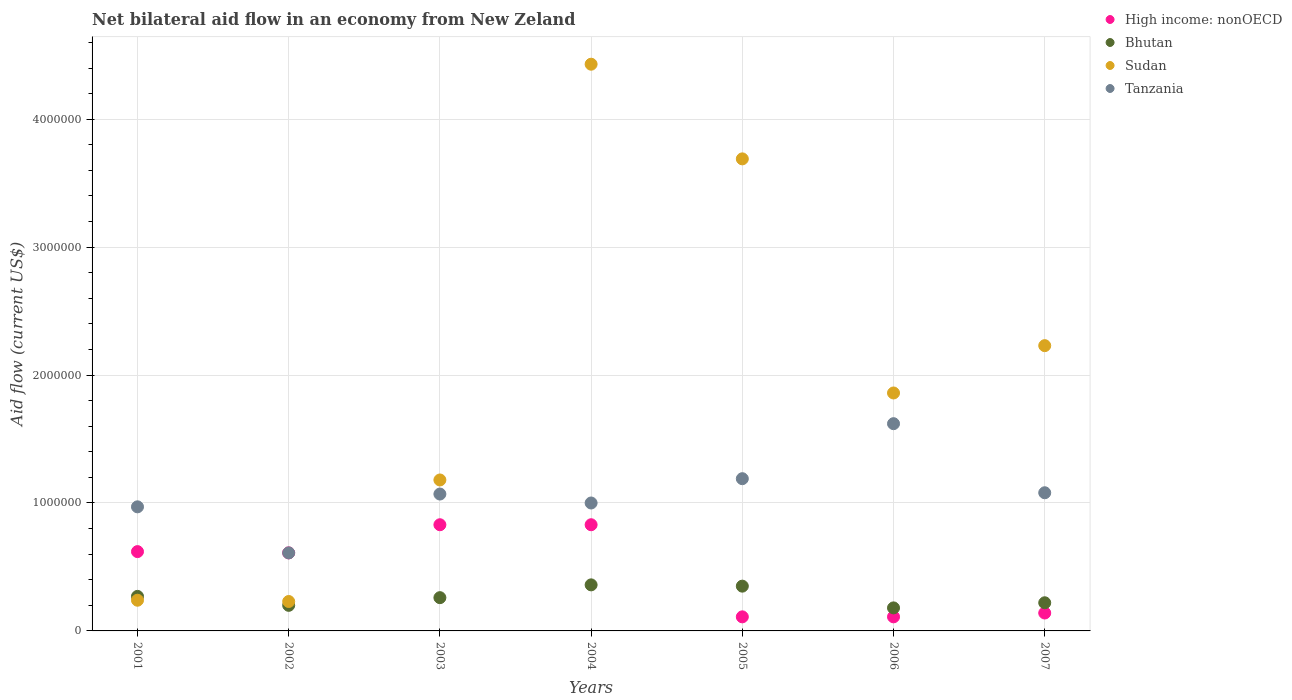Is the number of dotlines equal to the number of legend labels?
Your answer should be very brief. Yes. What is the net bilateral aid flow in Sudan in 2003?
Offer a terse response. 1.18e+06. Across all years, what is the maximum net bilateral aid flow in High income: nonOECD?
Make the answer very short. 8.30e+05. In which year was the net bilateral aid flow in Sudan maximum?
Provide a succinct answer. 2004. What is the total net bilateral aid flow in Tanzania in the graph?
Offer a very short reply. 7.54e+06. What is the difference between the net bilateral aid flow in High income: nonOECD in 2006 and that in 2007?
Offer a terse response. -3.00e+04. What is the difference between the net bilateral aid flow in High income: nonOECD in 2004 and the net bilateral aid flow in Sudan in 2003?
Your answer should be compact. -3.50e+05. What is the average net bilateral aid flow in Sudan per year?
Your answer should be compact. 1.98e+06. In the year 2005, what is the difference between the net bilateral aid flow in Bhutan and net bilateral aid flow in Sudan?
Offer a terse response. -3.34e+06. What is the ratio of the net bilateral aid flow in Bhutan in 2002 to that in 2004?
Offer a terse response. 0.56. Is the net bilateral aid flow in Sudan in 2005 less than that in 2006?
Keep it short and to the point. No. Is the difference between the net bilateral aid flow in Bhutan in 2003 and 2005 greater than the difference between the net bilateral aid flow in Sudan in 2003 and 2005?
Provide a succinct answer. Yes. What is the difference between the highest and the lowest net bilateral aid flow in Bhutan?
Make the answer very short. 1.80e+05. In how many years, is the net bilateral aid flow in Tanzania greater than the average net bilateral aid flow in Tanzania taken over all years?
Make the answer very short. 3. Is the sum of the net bilateral aid flow in Sudan in 2003 and 2007 greater than the maximum net bilateral aid flow in Bhutan across all years?
Ensure brevity in your answer.  Yes. Is it the case that in every year, the sum of the net bilateral aid flow in Tanzania and net bilateral aid flow in Sudan  is greater than the net bilateral aid flow in Bhutan?
Offer a terse response. Yes. Is the net bilateral aid flow in Tanzania strictly less than the net bilateral aid flow in High income: nonOECD over the years?
Give a very brief answer. No. How many dotlines are there?
Ensure brevity in your answer.  4. How many years are there in the graph?
Provide a succinct answer. 7. Are the values on the major ticks of Y-axis written in scientific E-notation?
Provide a short and direct response. No. Does the graph contain any zero values?
Ensure brevity in your answer.  No. Does the graph contain grids?
Offer a very short reply. Yes. How many legend labels are there?
Ensure brevity in your answer.  4. How are the legend labels stacked?
Give a very brief answer. Vertical. What is the title of the graph?
Provide a short and direct response. Net bilateral aid flow in an economy from New Zeland. What is the Aid flow (current US$) in High income: nonOECD in 2001?
Your answer should be compact. 6.20e+05. What is the Aid flow (current US$) of Bhutan in 2001?
Make the answer very short. 2.70e+05. What is the Aid flow (current US$) in Tanzania in 2001?
Offer a very short reply. 9.70e+05. What is the Aid flow (current US$) of High income: nonOECD in 2002?
Provide a succinct answer. 6.10e+05. What is the Aid flow (current US$) in Sudan in 2002?
Ensure brevity in your answer.  2.30e+05. What is the Aid flow (current US$) of High income: nonOECD in 2003?
Give a very brief answer. 8.30e+05. What is the Aid flow (current US$) in Bhutan in 2003?
Ensure brevity in your answer.  2.60e+05. What is the Aid flow (current US$) in Sudan in 2003?
Provide a succinct answer. 1.18e+06. What is the Aid flow (current US$) of Tanzania in 2003?
Your answer should be very brief. 1.07e+06. What is the Aid flow (current US$) of High income: nonOECD in 2004?
Offer a very short reply. 8.30e+05. What is the Aid flow (current US$) in Bhutan in 2004?
Provide a short and direct response. 3.60e+05. What is the Aid flow (current US$) in Sudan in 2004?
Offer a terse response. 4.43e+06. What is the Aid flow (current US$) in High income: nonOECD in 2005?
Offer a very short reply. 1.10e+05. What is the Aid flow (current US$) of Bhutan in 2005?
Ensure brevity in your answer.  3.50e+05. What is the Aid flow (current US$) in Sudan in 2005?
Your answer should be very brief. 3.69e+06. What is the Aid flow (current US$) of Tanzania in 2005?
Your answer should be compact. 1.19e+06. What is the Aid flow (current US$) of High income: nonOECD in 2006?
Offer a very short reply. 1.10e+05. What is the Aid flow (current US$) of Sudan in 2006?
Give a very brief answer. 1.86e+06. What is the Aid flow (current US$) of Tanzania in 2006?
Give a very brief answer. 1.62e+06. What is the Aid flow (current US$) in High income: nonOECD in 2007?
Your response must be concise. 1.40e+05. What is the Aid flow (current US$) of Sudan in 2007?
Offer a terse response. 2.23e+06. What is the Aid flow (current US$) of Tanzania in 2007?
Your answer should be very brief. 1.08e+06. Across all years, what is the maximum Aid flow (current US$) of High income: nonOECD?
Your answer should be very brief. 8.30e+05. Across all years, what is the maximum Aid flow (current US$) of Bhutan?
Provide a succinct answer. 3.60e+05. Across all years, what is the maximum Aid flow (current US$) in Sudan?
Give a very brief answer. 4.43e+06. Across all years, what is the maximum Aid flow (current US$) of Tanzania?
Offer a terse response. 1.62e+06. Across all years, what is the minimum Aid flow (current US$) in Bhutan?
Keep it short and to the point. 1.80e+05. Across all years, what is the minimum Aid flow (current US$) in Tanzania?
Give a very brief answer. 6.10e+05. What is the total Aid flow (current US$) of High income: nonOECD in the graph?
Provide a succinct answer. 3.25e+06. What is the total Aid flow (current US$) of Bhutan in the graph?
Your answer should be very brief. 1.84e+06. What is the total Aid flow (current US$) of Sudan in the graph?
Make the answer very short. 1.39e+07. What is the total Aid flow (current US$) in Tanzania in the graph?
Make the answer very short. 7.54e+06. What is the difference between the Aid flow (current US$) of High income: nonOECD in 2001 and that in 2002?
Your response must be concise. 10000. What is the difference between the Aid flow (current US$) of Sudan in 2001 and that in 2002?
Keep it short and to the point. 10000. What is the difference between the Aid flow (current US$) in Tanzania in 2001 and that in 2002?
Make the answer very short. 3.60e+05. What is the difference between the Aid flow (current US$) in High income: nonOECD in 2001 and that in 2003?
Your answer should be very brief. -2.10e+05. What is the difference between the Aid flow (current US$) of Sudan in 2001 and that in 2003?
Your response must be concise. -9.40e+05. What is the difference between the Aid flow (current US$) in Tanzania in 2001 and that in 2003?
Make the answer very short. -1.00e+05. What is the difference between the Aid flow (current US$) of Sudan in 2001 and that in 2004?
Make the answer very short. -4.19e+06. What is the difference between the Aid flow (current US$) of High income: nonOECD in 2001 and that in 2005?
Provide a succinct answer. 5.10e+05. What is the difference between the Aid flow (current US$) in Bhutan in 2001 and that in 2005?
Your response must be concise. -8.00e+04. What is the difference between the Aid flow (current US$) in Sudan in 2001 and that in 2005?
Offer a terse response. -3.45e+06. What is the difference between the Aid flow (current US$) of High income: nonOECD in 2001 and that in 2006?
Your answer should be very brief. 5.10e+05. What is the difference between the Aid flow (current US$) of Sudan in 2001 and that in 2006?
Make the answer very short. -1.62e+06. What is the difference between the Aid flow (current US$) in Tanzania in 2001 and that in 2006?
Give a very brief answer. -6.50e+05. What is the difference between the Aid flow (current US$) of High income: nonOECD in 2001 and that in 2007?
Provide a succinct answer. 4.80e+05. What is the difference between the Aid flow (current US$) of Sudan in 2001 and that in 2007?
Your answer should be compact. -1.99e+06. What is the difference between the Aid flow (current US$) of Tanzania in 2001 and that in 2007?
Your answer should be compact. -1.10e+05. What is the difference between the Aid flow (current US$) in Sudan in 2002 and that in 2003?
Make the answer very short. -9.50e+05. What is the difference between the Aid flow (current US$) in Tanzania in 2002 and that in 2003?
Give a very brief answer. -4.60e+05. What is the difference between the Aid flow (current US$) in Bhutan in 2002 and that in 2004?
Offer a terse response. -1.60e+05. What is the difference between the Aid flow (current US$) of Sudan in 2002 and that in 2004?
Your answer should be very brief. -4.20e+06. What is the difference between the Aid flow (current US$) in Tanzania in 2002 and that in 2004?
Provide a short and direct response. -3.90e+05. What is the difference between the Aid flow (current US$) of High income: nonOECD in 2002 and that in 2005?
Your response must be concise. 5.00e+05. What is the difference between the Aid flow (current US$) in Sudan in 2002 and that in 2005?
Make the answer very short. -3.46e+06. What is the difference between the Aid flow (current US$) of Tanzania in 2002 and that in 2005?
Give a very brief answer. -5.80e+05. What is the difference between the Aid flow (current US$) of High income: nonOECD in 2002 and that in 2006?
Offer a very short reply. 5.00e+05. What is the difference between the Aid flow (current US$) in Bhutan in 2002 and that in 2006?
Offer a very short reply. 2.00e+04. What is the difference between the Aid flow (current US$) in Sudan in 2002 and that in 2006?
Your answer should be compact. -1.63e+06. What is the difference between the Aid flow (current US$) in Tanzania in 2002 and that in 2006?
Keep it short and to the point. -1.01e+06. What is the difference between the Aid flow (current US$) of Sudan in 2002 and that in 2007?
Keep it short and to the point. -2.00e+06. What is the difference between the Aid flow (current US$) in Tanzania in 2002 and that in 2007?
Give a very brief answer. -4.70e+05. What is the difference between the Aid flow (current US$) in Sudan in 2003 and that in 2004?
Provide a succinct answer. -3.25e+06. What is the difference between the Aid flow (current US$) in Tanzania in 2003 and that in 2004?
Provide a succinct answer. 7.00e+04. What is the difference between the Aid flow (current US$) of High income: nonOECD in 2003 and that in 2005?
Your answer should be compact. 7.20e+05. What is the difference between the Aid flow (current US$) of Bhutan in 2003 and that in 2005?
Provide a succinct answer. -9.00e+04. What is the difference between the Aid flow (current US$) of Sudan in 2003 and that in 2005?
Your answer should be compact. -2.51e+06. What is the difference between the Aid flow (current US$) of Tanzania in 2003 and that in 2005?
Provide a short and direct response. -1.20e+05. What is the difference between the Aid flow (current US$) of High income: nonOECD in 2003 and that in 2006?
Your answer should be compact. 7.20e+05. What is the difference between the Aid flow (current US$) in Bhutan in 2003 and that in 2006?
Offer a terse response. 8.00e+04. What is the difference between the Aid flow (current US$) of Sudan in 2003 and that in 2006?
Your answer should be compact. -6.80e+05. What is the difference between the Aid flow (current US$) of Tanzania in 2003 and that in 2006?
Offer a very short reply. -5.50e+05. What is the difference between the Aid flow (current US$) of High income: nonOECD in 2003 and that in 2007?
Keep it short and to the point. 6.90e+05. What is the difference between the Aid flow (current US$) of Sudan in 2003 and that in 2007?
Provide a succinct answer. -1.05e+06. What is the difference between the Aid flow (current US$) in Tanzania in 2003 and that in 2007?
Provide a succinct answer. -10000. What is the difference between the Aid flow (current US$) of High income: nonOECD in 2004 and that in 2005?
Your answer should be very brief. 7.20e+05. What is the difference between the Aid flow (current US$) in Bhutan in 2004 and that in 2005?
Your answer should be very brief. 10000. What is the difference between the Aid flow (current US$) of Sudan in 2004 and that in 2005?
Offer a terse response. 7.40e+05. What is the difference between the Aid flow (current US$) of High income: nonOECD in 2004 and that in 2006?
Offer a terse response. 7.20e+05. What is the difference between the Aid flow (current US$) in Sudan in 2004 and that in 2006?
Provide a short and direct response. 2.57e+06. What is the difference between the Aid flow (current US$) in Tanzania in 2004 and that in 2006?
Your answer should be compact. -6.20e+05. What is the difference between the Aid flow (current US$) of High income: nonOECD in 2004 and that in 2007?
Your answer should be compact. 6.90e+05. What is the difference between the Aid flow (current US$) in Bhutan in 2004 and that in 2007?
Keep it short and to the point. 1.40e+05. What is the difference between the Aid flow (current US$) in Sudan in 2004 and that in 2007?
Ensure brevity in your answer.  2.20e+06. What is the difference between the Aid flow (current US$) in Tanzania in 2004 and that in 2007?
Ensure brevity in your answer.  -8.00e+04. What is the difference between the Aid flow (current US$) of High income: nonOECD in 2005 and that in 2006?
Offer a terse response. 0. What is the difference between the Aid flow (current US$) in Sudan in 2005 and that in 2006?
Ensure brevity in your answer.  1.83e+06. What is the difference between the Aid flow (current US$) in Tanzania in 2005 and that in 2006?
Give a very brief answer. -4.30e+05. What is the difference between the Aid flow (current US$) of Sudan in 2005 and that in 2007?
Your answer should be compact. 1.46e+06. What is the difference between the Aid flow (current US$) in Tanzania in 2005 and that in 2007?
Give a very brief answer. 1.10e+05. What is the difference between the Aid flow (current US$) of Bhutan in 2006 and that in 2007?
Make the answer very short. -4.00e+04. What is the difference between the Aid flow (current US$) of Sudan in 2006 and that in 2007?
Make the answer very short. -3.70e+05. What is the difference between the Aid flow (current US$) of Tanzania in 2006 and that in 2007?
Your response must be concise. 5.40e+05. What is the difference between the Aid flow (current US$) of High income: nonOECD in 2001 and the Aid flow (current US$) of Bhutan in 2002?
Your response must be concise. 4.20e+05. What is the difference between the Aid flow (current US$) in High income: nonOECD in 2001 and the Aid flow (current US$) in Sudan in 2002?
Keep it short and to the point. 3.90e+05. What is the difference between the Aid flow (current US$) of High income: nonOECD in 2001 and the Aid flow (current US$) of Tanzania in 2002?
Provide a succinct answer. 10000. What is the difference between the Aid flow (current US$) in Bhutan in 2001 and the Aid flow (current US$) in Sudan in 2002?
Your answer should be very brief. 4.00e+04. What is the difference between the Aid flow (current US$) in Bhutan in 2001 and the Aid flow (current US$) in Tanzania in 2002?
Give a very brief answer. -3.40e+05. What is the difference between the Aid flow (current US$) in Sudan in 2001 and the Aid flow (current US$) in Tanzania in 2002?
Ensure brevity in your answer.  -3.70e+05. What is the difference between the Aid flow (current US$) in High income: nonOECD in 2001 and the Aid flow (current US$) in Sudan in 2003?
Ensure brevity in your answer.  -5.60e+05. What is the difference between the Aid flow (current US$) in High income: nonOECD in 2001 and the Aid flow (current US$) in Tanzania in 2003?
Ensure brevity in your answer.  -4.50e+05. What is the difference between the Aid flow (current US$) in Bhutan in 2001 and the Aid flow (current US$) in Sudan in 2003?
Offer a very short reply. -9.10e+05. What is the difference between the Aid flow (current US$) in Bhutan in 2001 and the Aid flow (current US$) in Tanzania in 2003?
Ensure brevity in your answer.  -8.00e+05. What is the difference between the Aid flow (current US$) of Sudan in 2001 and the Aid flow (current US$) of Tanzania in 2003?
Your answer should be compact. -8.30e+05. What is the difference between the Aid flow (current US$) of High income: nonOECD in 2001 and the Aid flow (current US$) of Sudan in 2004?
Your response must be concise. -3.81e+06. What is the difference between the Aid flow (current US$) in High income: nonOECD in 2001 and the Aid flow (current US$) in Tanzania in 2004?
Ensure brevity in your answer.  -3.80e+05. What is the difference between the Aid flow (current US$) in Bhutan in 2001 and the Aid flow (current US$) in Sudan in 2004?
Your answer should be very brief. -4.16e+06. What is the difference between the Aid flow (current US$) of Bhutan in 2001 and the Aid flow (current US$) of Tanzania in 2004?
Ensure brevity in your answer.  -7.30e+05. What is the difference between the Aid flow (current US$) in Sudan in 2001 and the Aid flow (current US$) in Tanzania in 2004?
Keep it short and to the point. -7.60e+05. What is the difference between the Aid flow (current US$) in High income: nonOECD in 2001 and the Aid flow (current US$) in Sudan in 2005?
Offer a very short reply. -3.07e+06. What is the difference between the Aid flow (current US$) of High income: nonOECD in 2001 and the Aid flow (current US$) of Tanzania in 2005?
Your answer should be very brief. -5.70e+05. What is the difference between the Aid flow (current US$) of Bhutan in 2001 and the Aid flow (current US$) of Sudan in 2005?
Your answer should be compact. -3.42e+06. What is the difference between the Aid flow (current US$) of Bhutan in 2001 and the Aid flow (current US$) of Tanzania in 2005?
Give a very brief answer. -9.20e+05. What is the difference between the Aid flow (current US$) of Sudan in 2001 and the Aid flow (current US$) of Tanzania in 2005?
Offer a terse response. -9.50e+05. What is the difference between the Aid flow (current US$) of High income: nonOECD in 2001 and the Aid flow (current US$) of Bhutan in 2006?
Keep it short and to the point. 4.40e+05. What is the difference between the Aid flow (current US$) in High income: nonOECD in 2001 and the Aid flow (current US$) in Sudan in 2006?
Give a very brief answer. -1.24e+06. What is the difference between the Aid flow (current US$) of Bhutan in 2001 and the Aid flow (current US$) of Sudan in 2006?
Ensure brevity in your answer.  -1.59e+06. What is the difference between the Aid flow (current US$) of Bhutan in 2001 and the Aid flow (current US$) of Tanzania in 2006?
Your answer should be compact. -1.35e+06. What is the difference between the Aid flow (current US$) in Sudan in 2001 and the Aid flow (current US$) in Tanzania in 2006?
Provide a short and direct response. -1.38e+06. What is the difference between the Aid flow (current US$) of High income: nonOECD in 2001 and the Aid flow (current US$) of Bhutan in 2007?
Offer a very short reply. 4.00e+05. What is the difference between the Aid flow (current US$) in High income: nonOECD in 2001 and the Aid flow (current US$) in Sudan in 2007?
Make the answer very short. -1.61e+06. What is the difference between the Aid flow (current US$) of High income: nonOECD in 2001 and the Aid flow (current US$) of Tanzania in 2007?
Offer a terse response. -4.60e+05. What is the difference between the Aid flow (current US$) of Bhutan in 2001 and the Aid flow (current US$) of Sudan in 2007?
Give a very brief answer. -1.96e+06. What is the difference between the Aid flow (current US$) of Bhutan in 2001 and the Aid flow (current US$) of Tanzania in 2007?
Provide a short and direct response. -8.10e+05. What is the difference between the Aid flow (current US$) of Sudan in 2001 and the Aid flow (current US$) of Tanzania in 2007?
Give a very brief answer. -8.40e+05. What is the difference between the Aid flow (current US$) of High income: nonOECD in 2002 and the Aid flow (current US$) of Sudan in 2003?
Provide a short and direct response. -5.70e+05. What is the difference between the Aid flow (current US$) in High income: nonOECD in 2002 and the Aid flow (current US$) in Tanzania in 2003?
Make the answer very short. -4.60e+05. What is the difference between the Aid flow (current US$) in Bhutan in 2002 and the Aid flow (current US$) in Sudan in 2003?
Your answer should be very brief. -9.80e+05. What is the difference between the Aid flow (current US$) of Bhutan in 2002 and the Aid flow (current US$) of Tanzania in 2003?
Give a very brief answer. -8.70e+05. What is the difference between the Aid flow (current US$) of Sudan in 2002 and the Aid flow (current US$) of Tanzania in 2003?
Your response must be concise. -8.40e+05. What is the difference between the Aid flow (current US$) in High income: nonOECD in 2002 and the Aid flow (current US$) in Sudan in 2004?
Ensure brevity in your answer.  -3.82e+06. What is the difference between the Aid flow (current US$) of High income: nonOECD in 2002 and the Aid flow (current US$) of Tanzania in 2004?
Offer a terse response. -3.90e+05. What is the difference between the Aid flow (current US$) of Bhutan in 2002 and the Aid flow (current US$) of Sudan in 2004?
Give a very brief answer. -4.23e+06. What is the difference between the Aid flow (current US$) in Bhutan in 2002 and the Aid flow (current US$) in Tanzania in 2004?
Your answer should be compact. -8.00e+05. What is the difference between the Aid flow (current US$) in Sudan in 2002 and the Aid flow (current US$) in Tanzania in 2004?
Make the answer very short. -7.70e+05. What is the difference between the Aid flow (current US$) in High income: nonOECD in 2002 and the Aid flow (current US$) in Sudan in 2005?
Your answer should be compact. -3.08e+06. What is the difference between the Aid flow (current US$) in High income: nonOECD in 2002 and the Aid flow (current US$) in Tanzania in 2005?
Offer a very short reply. -5.80e+05. What is the difference between the Aid flow (current US$) of Bhutan in 2002 and the Aid flow (current US$) of Sudan in 2005?
Offer a very short reply. -3.49e+06. What is the difference between the Aid flow (current US$) of Bhutan in 2002 and the Aid flow (current US$) of Tanzania in 2005?
Give a very brief answer. -9.90e+05. What is the difference between the Aid flow (current US$) of Sudan in 2002 and the Aid flow (current US$) of Tanzania in 2005?
Your answer should be compact. -9.60e+05. What is the difference between the Aid flow (current US$) of High income: nonOECD in 2002 and the Aid flow (current US$) of Bhutan in 2006?
Ensure brevity in your answer.  4.30e+05. What is the difference between the Aid flow (current US$) of High income: nonOECD in 2002 and the Aid flow (current US$) of Sudan in 2006?
Give a very brief answer. -1.25e+06. What is the difference between the Aid flow (current US$) of High income: nonOECD in 2002 and the Aid flow (current US$) of Tanzania in 2006?
Offer a terse response. -1.01e+06. What is the difference between the Aid flow (current US$) of Bhutan in 2002 and the Aid flow (current US$) of Sudan in 2006?
Make the answer very short. -1.66e+06. What is the difference between the Aid flow (current US$) in Bhutan in 2002 and the Aid flow (current US$) in Tanzania in 2006?
Give a very brief answer. -1.42e+06. What is the difference between the Aid flow (current US$) of Sudan in 2002 and the Aid flow (current US$) of Tanzania in 2006?
Provide a short and direct response. -1.39e+06. What is the difference between the Aid flow (current US$) of High income: nonOECD in 2002 and the Aid flow (current US$) of Bhutan in 2007?
Give a very brief answer. 3.90e+05. What is the difference between the Aid flow (current US$) of High income: nonOECD in 2002 and the Aid flow (current US$) of Sudan in 2007?
Ensure brevity in your answer.  -1.62e+06. What is the difference between the Aid flow (current US$) in High income: nonOECD in 2002 and the Aid flow (current US$) in Tanzania in 2007?
Give a very brief answer. -4.70e+05. What is the difference between the Aid flow (current US$) in Bhutan in 2002 and the Aid flow (current US$) in Sudan in 2007?
Give a very brief answer. -2.03e+06. What is the difference between the Aid flow (current US$) of Bhutan in 2002 and the Aid flow (current US$) of Tanzania in 2007?
Your response must be concise. -8.80e+05. What is the difference between the Aid flow (current US$) in Sudan in 2002 and the Aid flow (current US$) in Tanzania in 2007?
Keep it short and to the point. -8.50e+05. What is the difference between the Aid flow (current US$) of High income: nonOECD in 2003 and the Aid flow (current US$) of Sudan in 2004?
Provide a succinct answer. -3.60e+06. What is the difference between the Aid flow (current US$) in High income: nonOECD in 2003 and the Aid flow (current US$) in Tanzania in 2004?
Offer a terse response. -1.70e+05. What is the difference between the Aid flow (current US$) of Bhutan in 2003 and the Aid flow (current US$) of Sudan in 2004?
Provide a short and direct response. -4.17e+06. What is the difference between the Aid flow (current US$) of Bhutan in 2003 and the Aid flow (current US$) of Tanzania in 2004?
Offer a very short reply. -7.40e+05. What is the difference between the Aid flow (current US$) of High income: nonOECD in 2003 and the Aid flow (current US$) of Bhutan in 2005?
Your answer should be compact. 4.80e+05. What is the difference between the Aid flow (current US$) in High income: nonOECD in 2003 and the Aid flow (current US$) in Sudan in 2005?
Give a very brief answer. -2.86e+06. What is the difference between the Aid flow (current US$) of High income: nonOECD in 2003 and the Aid flow (current US$) of Tanzania in 2005?
Your response must be concise. -3.60e+05. What is the difference between the Aid flow (current US$) in Bhutan in 2003 and the Aid flow (current US$) in Sudan in 2005?
Your answer should be compact. -3.43e+06. What is the difference between the Aid flow (current US$) of Bhutan in 2003 and the Aid flow (current US$) of Tanzania in 2005?
Offer a terse response. -9.30e+05. What is the difference between the Aid flow (current US$) in High income: nonOECD in 2003 and the Aid flow (current US$) in Bhutan in 2006?
Provide a short and direct response. 6.50e+05. What is the difference between the Aid flow (current US$) in High income: nonOECD in 2003 and the Aid flow (current US$) in Sudan in 2006?
Keep it short and to the point. -1.03e+06. What is the difference between the Aid flow (current US$) of High income: nonOECD in 2003 and the Aid flow (current US$) of Tanzania in 2006?
Give a very brief answer. -7.90e+05. What is the difference between the Aid flow (current US$) in Bhutan in 2003 and the Aid flow (current US$) in Sudan in 2006?
Offer a terse response. -1.60e+06. What is the difference between the Aid flow (current US$) in Bhutan in 2003 and the Aid flow (current US$) in Tanzania in 2006?
Ensure brevity in your answer.  -1.36e+06. What is the difference between the Aid flow (current US$) in Sudan in 2003 and the Aid flow (current US$) in Tanzania in 2006?
Your response must be concise. -4.40e+05. What is the difference between the Aid flow (current US$) in High income: nonOECD in 2003 and the Aid flow (current US$) in Bhutan in 2007?
Ensure brevity in your answer.  6.10e+05. What is the difference between the Aid flow (current US$) of High income: nonOECD in 2003 and the Aid flow (current US$) of Sudan in 2007?
Make the answer very short. -1.40e+06. What is the difference between the Aid flow (current US$) of High income: nonOECD in 2003 and the Aid flow (current US$) of Tanzania in 2007?
Your response must be concise. -2.50e+05. What is the difference between the Aid flow (current US$) in Bhutan in 2003 and the Aid flow (current US$) in Sudan in 2007?
Give a very brief answer. -1.97e+06. What is the difference between the Aid flow (current US$) of Bhutan in 2003 and the Aid flow (current US$) of Tanzania in 2007?
Make the answer very short. -8.20e+05. What is the difference between the Aid flow (current US$) in Sudan in 2003 and the Aid flow (current US$) in Tanzania in 2007?
Make the answer very short. 1.00e+05. What is the difference between the Aid flow (current US$) of High income: nonOECD in 2004 and the Aid flow (current US$) of Sudan in 2005?
Your response must be concise. -2.86e+06. What is the difference between the Aid flow (current US$) in High income: nonOECD in 2004 and the Aid flow (current US$) in Tanzania in 2005?
Offer a very short reply. -3.60e+05. What is the difference between the Aid flow (current US$) in Bhutan in 2004 and the Aid flow (current US$) in Sudan in 2005?
Give a very brief answer. -3.33e+06. What is the difference between the Aid flow (current US$) of Bhutan in 2004 and the Aid flow (current US$) of Tanzania in 2005?
Your answer should be compact. -8.30e+05. What is the difference between the Aid flow (current US$) of Sudan in 2004 and the Aid flow (current US$) of Tanzania in 2005?
Your answer should be compact. 3.24e+06. What is the difference between the Aid flow (current US$) of High income: nonOECD in 2004 and the Aid flow (current US$) of Bhutan in 2006?
Give a very brief answer. 6.50e+05. What is the difference between the Aid flow (current US$) in High income: nonOECD in 2004 and the Aid flow (current US$) in Sudan in 2006?
Provide a succinct answer. -1.03e+06. What is the difference between the Aid flow (current US$) of High income: nonOECD in 2004 and the Aid flow (current US$) of Tanzania in 2006?
Give a very brief answer. -7.90e+05. What is the difference between the Aid flow (current US$) of Bhutan in 2004 and the Aid flow (current US$) of Sudan in 2006?
Provide a short and direct response. -1.50e+06. What is the difference between the Aid flow (current US$) of Bhutan in 2004 and the Aid flow (current US$) of Tanzania in 2006?
Offer a terse response. -1.26e+06. What is the difference between the Aid flow (current US$) in Sudan in 2004 and the Aid flow (current US$) in Tanzania in 2006?
Give a very brief answer. 2.81e+06. What is the difference between the Aid flow (current US$) of High income: nonOECD in 2004 and the Aid flow (current US$) of Sudan in 2007?
Keep it short and to the point. -1.40e+06. What is the difference between the Aid flow (current US$) in Bhutan in 2004 and the Aid flow (current US$) in Sudan in 2007?
Make the answer very short. -1.87e+06. What is the difference between the Aid flow (current US$) in Bhutan in 2004 and the Aid flow (current US$) in Tanzania in 2007?
Ensure brevity in your answer.  -7.20e+05. What is the difference between the Aid flow (current US$) in Sudan in 2004 and the Aid flow (current US$) in Tanzania in 2007?
Keep it short and to the point. 3.35e+06. What is the difference between the Aid flow (current US$) in High income: nonOECD in 2005 and the Aid flow (current US$) in Sudan in 2006?
Ensure brevity in your answer.  -1.75e+06. What is the difference between the Aid flow (current US$) in High income: nonOECD in 2005 and the Aid flow (current US$) in Tanzania in 2006?
Provide a short and direct response. -1.51e+06. What is the difference between the Aid flow (current US$) in Bhutan in 2005 and the Aid flow (current US$) in Sudan in 2006?
Provide a succinct answer. -1.51e+06. What is the difference between the Aid flow (current US$) in Bhutan in 2005 and the Aid flow (current US$) in Tanzania in 2006?
Your answer should be very brief. -1.27e+06. What is the difference between the Aid flow (current US$) in Sudan in 2005 and the Aid flow (current US$) in Tanzania in 2006?
Give a very brief answer. 2.07e+06. What is the difference between the Aid flow (current US$) of High income: nonOECD in 2005 and the Aid flow (current US$) of Bhutan in 2007?
Keep it short and to the point. -1.10e+05. What is the difference between the Aid flow (current US$) of High income: nonOECD in 2005 and the Aid flow (current US$) of Sudan in 2007?
Your answer should be compact. -2.12e+06. What is the difference between the Aid flow (current US$) in High income: nonOECD in 2005 and the Aid flow (current US$) in Tanzania in 2007?
Make the answer very short. -9.70e+05. What is the difference between the Aid flow (current US$) in Bhutan in 2005 and the Aid flow (current US$) in Sudan in 2007?
Make the answer very short. -1.88e+06. What is the difference between the Aid flow (current US$) in Bhutan in 2005 and the Aid flow (current US$) in Tanzania in 2007?
Provide a succinct answer. -7.30e+05. What is the difference between the Aid flow (current US$) of Sudan in 2005 and the Aid flow (current US$) of Tanzania in 2007?
Your answer should be compact. 2.61e+06. What is the difference between the Aid flow (current US$) in High income: nonOECD in 2006 and the Aid flow (current US$) in Bhutan in 2007?
Keep it short and to the point. -1.10e+05. What is the difference between the Aid flow (current US$) in High income: nonOECD in 2006 and the Aid flow (current US$) in Sudan in 2007?
Offer a terse response. -2.12e+06. What is the difference between the Aid flow (current US$) of High income: nonOECD in 2006 and the Aid flow (current US$) of Tanzania in 2007?
Offer a terse response. -9.70e+05. What is the difference between the Aid flow (current US$) in Bhutan in 2006 and the Aid flow (current US$) in Sudan in 2007?
Your answer should be compact. -2.05e+06. What is the difference between the Aid flow (current US$) of Bhutan in 2006 and the Aid flow (current US$) of Tanzania in 2007?
Your answer should be compact. -9.00e+05. What is the difference between the Aid flow (current US$) of Sudan in 2006 and the Aid flow (current US$) of Tanzania in 2007?
Your answer should be very brief. 7.80e+05. What is the average Aid flow (current US$) in High income: nonOECD per year?
Make the answer very short. 4.64e+05. What is the average Aid flow (current US$) in Bhutan per year?
Keep it short and to the point. 2.63e+05. What is the average Aid flow (current US$) in Sudan per year?
Provide a short and direct response. 1.98e+06. What is the average Aid flow (current US$) in Tanzania per year?
Provide a succinct answer. 1.08e+06. In the year 2001, what is the difference between the Aid flow (current US$) in High income: nonOECD and Aid flow (current US$) in Tanzania?
Keep it short and to the point. -3.50e+05. In the year 2001, what is the difference between the Aid flow (current US$) in Bhutan and Aid flow (current US$) in Tanzania?
Ensure brevity in your answer.  -7.00e+05. In the year 2001, what is the difference between the Aid flow (current US$) of Sudan and Aid flow (current US$) of Tanzania?
Your response must be concise. -7.30e+05. In the year 2002, what is the difference between the Aid flow (current US$) in High income: nonOECD and Aid flow (current US$) in Bhutan?
Offer a very short reply. 4.10e+05. In the year 2002, what is the difference between the Aid flow (current US$) in High income: nonOECD and Aid flow (current US$) in Tanzania?
Your answer should be compact. 0. In the year 2002, what is the difference between the Aid flow (current US$) of Bhutan and Aid flow (current US$) of Sudan?
Your answer should be very brief. -3.00e+04. In the year 2002, what is the difference between the Aid flow (current US$) of Bhutan and Aid flow (current US$) of Tanzania?
Provide a short and direct response. -4.10e+05. In the year 2002, what is the difference between the Aid flow (current US$) of Sudan and Aid flow (current US$) of Tanzania?
Ensure brevity in your answer.  -3.80e+05. In the year 2003, what is the difference between the Aid flow (current US$) in High income: nonOECD and Aid flow (current US$) in Bhutan?
Your answer should be compact. 5.70e+05. In the year 2003, what is the difference between the Aid flow (current US$) in High income: nonOECD and Aid flow (current US$) in Sudan?
Make the answer very short. -3.50e+05. In the year 2003, what is the difference between the Aid flow (current US$) in High income: nonOECD and Aid flow (current US$) in Tanzania?
Your response must be concise. -2.40e+05. In the year 2003, what is the difference between the Aid flow (current US$) of Bhutan and Aid flow (current US$) of Sudan?
Make the answer very short. -9.20e+05. In the year 2003, what is the difference between the Aid flow (current US$) in Bhutan and Aid flow (current US$) in Tanzania?
Provide a short and direct response. -8.10e+05. In the year 2003, what is the difference between the Aid flow (current US$) in Sudan and Aid flow (current US$) in Tanzania?
Ensure brevity in your answer.  1.10e+05. In the year 2004, what is the difference between the Aid flow (current US$) of High income: nonOECD and Aid flow (current US$) of Bhutan?
Your answer should be compact. 4.70e+05. In the year 2004, what is the difference between the Aid flow (current US$) in High income: nonOECD and Aid flow (current US$) in Sudan?
Make the answer very short. -3.60e+06. In the year 2004, what is the difference between the Aid flow (current US$) of Bhutan and Aid flow (current US$) of Sudan?
Your answer should be compact. -4.07e+06. In the year 2004, what is the difference between the Aid flow (current US$) of Bhutan and Aid flow (current US$) of Tanzania?
Offer a very short reply. -6.40e+05. In the year 2004, what is the difference between the Aid flow (current US$) of Sudan and Aid flow (current US$) of Tanzania?
Offer a terse response. 3.43e+06. In the year 2005, what is the difference between the Aid flow (current US$) in High income: nonOECD and Aid flow (current US$) in Bhutan?
Provide a short and direct response. -2.40e+05. In the year 2005, what is the difference between the Aid flow (current US$) in High income: nonOECD and Aid flow (current US$) in Sudan?
Make the answer very short. -3.58e+06. In the year 2005, what is the difference between the Aid flow (current US$) of High income: nonOECD and Aid flow (current US$) of Tanzania?
Offer a terse response. -1.08e+06. In the year 2005, what is the difference between the Aid flow (current US$) of Bhutan and Aid flow (current US$) of Sudan?
Provide a succinct answer. -3.34e+06. In the year 2005, what is the difference between the Aid flow (current US$) in Bhutan and Aid flow (current US$) in Tanzania?
Keep it short and to the point. -8.40e+05. In the year 2005, what is the difference between the Aid flow (current US$) in Sudan and Aid flow (current US$) in Tanzania?
Your response must be concise. 2.50e+06. In the year 2006, what is the difference between the Aid flow (current US$) of High income: nonOECD and Aid flow (current US$) of Sudan?
Offer a terse response. -1.75e+06. In the year 2006, what is the difference between the Aid flow (current US$) of High income: nonOECD and Aid flow (current US$) of Tanzania?
Provide a succinct answer. -1.51e+06. In the year 2006, what is the difference between the Aid flow (current US$) of Bhutan and Aid flow (current US$) of Sudan?
Make the answer very short. -1.68e+06. In the year 2006, what is the difference between the Aid flow (current US$) of Bhutan and Aid flow (current US$) of Tanzania?
Provide a succinct answer. -1.44e+06. In the year 2006, what is the difference between the Aid flow (current US$) of Sudan and Aid flow (current US$) of Tanzania?
Your answer should be very brief. 2.40e+05. In the year 2007, what is the difference between the Aid flow (current US$) of High income: nonOECD and Aid flow (current US$) of Bhutan?
Provide a succinct answer. -8.00e+04. In the year 2007, what is the difference between the Aid flow (current US$) of High income: nonOECD and Aid flow (current US$) of Sudan?
Ensure brevity in your answer.  -2.09e+06. In the year 2007, what is the difference between the Aid flow (current US$) in High income: nonOECD and Aid flow (current US$) in Tanzania?
Offer a very short reply. -9.40e+05. In the year 2007, what is the difference between the Aid flow (current US$) in Bhutan and Aid flow (current US$) in Sudan?
Give a very brief answer. -2.01e+06. In the year 2007, what is the difference between the Aid flow (current US$) in Bhutan and Aid flow (current US$) in Tanzania?
Provide a succinct answer. -8.60e+05. In the year 2007, what is the difference between the Aid flow (current US$) of Sudan and Aid flow (current US$) of Tanzania?
Your answer should be very brief. 1.15e+06. What is the ratio of the Aid flow (current US$) of High income: nonOECD in 2001 to that in 2002?
Offer a very short reply. 1.02. What is the ratio of the Aid flow (current US$) in Bhutan in 2001 to that in 2002?
Offer a very short reply. 1.35. What is the ratio of the Aid flow (current US$) of Sudan in 2001 to that in 2002?
Your answer should be compact. 1.04. What is the ratio of the Aid flow (current US$) of Tanzania in 2001 to that in 2002?
Give a very brief answer. 1.59. What is the ratio of the Aid flow (current US$) in High income: nonOECD in 2001 to that in 2003?
Provide a short and direct response. 0.75. What is the ratio of the Aid flow (current US$) of Sudan in 2001 to that in 2003?
Provide a short and direct response. 0.2. What is the ratio of the Aid flow (current US$) of Tanzania in 2001 to that in 2003?
Make the answer very short. 0.91. What is the ratio of the Aid flow (current US$) in High income: nonOECD in 2001 to that in 2004?
Ensure brevity in your answer.  0.75. What is the ratio of the Aid flow (current US$) in Bhutan in 2001 to that in 2004?
Your response must be concise. 0.75. What is the ratio of the Aid flow (current US$) of Sudan in 2001 to that in 2004?
Offer a very short reply. 0.05. What is the ratio of the Aid flow (current US$) of Tanzania in 2001 to that in 2004?
Your answer should be very brief. 0.97. What is the ratio of the Aid flow (current US$) of High income: nonOECD in 2001 to that in 2005?
Offer a terse response. 5.64. What is the ratio of the Aid flow (current US$) in Bhutan in 2001 to that in 2005?
Keep it short and to the point. 0.77. What is the ratio of the Aid flow (current US$) of Sudan in 2001 to that in 2005?
Your response must be concise. 0.07. What is the ratio of the Aid flow (current US$) in Tanzania in 2001 to that in 2005?
Your answer should be very brief. 0.82. What is the ratio of the Aid flow (current US$) in High income: nonOECD in 2001 to that in 2006?
Offer a terse response. 5.64. What is the ratio of the Aid flow (current US$) of Sudan in 2001 to that in 2006?
Offer a terse response. 0.13. What is the ratio of the Aid flow (current US$) in Tanzania in 2001 to that in 2006?
Your answer should be very brief. 0.6. What is the ratio of the Aid flow (current US$) in High income: nonOECD in 2001 to that in 2007?
Your answer should be compact. 4.43. What is the ratio of the Aid flow (current US$) in Bhutan in 2001 to that in 2007?
Give a very brief answer. 1.23. What is the ratio of the Aid flow (current US$) in Sudan in 2001 to that in 2007?
Offer a terse response. 0.11. What is the ratio of the Aid flow (current US$) of Tanzania in 2001 to that in 2007?
Your response must be concise. 0.9. What is the ratio of the Aid flow (current US$) in High income: nonOECD in 2002 to that in 2003?
Make the answer very short. 0.73. What is the ratio of the Aid flow (current US$) in Bhutan in 2002 to that in 2003?
Ensure brevity in your answer.  0.77. What is the ratio of the Aid flow (current US$) in Sudan in 2002 to that in 2003?
Provide a short and direct response. 0.19. What is the ratio of the Aid flow (current US$) in Tanzania in 2002 to that in 2003?
Your answer should be compact. 0.57. What is the ratio of the Aid flow (current US$) of High income: nonOECD in 2002 to that in 2004?
Provide a short and direct response. 0.73. What is the ratio of the Aid flow (current US$) of Bhutan in 2002 to that in 2004?
Ensure brevity in your answer.  0.56. What is the ratio of the Aid flow (current US$) of Sudan in 2002 to that in 2004?
Offer a very short reply. 0.05. What is the ratio of the Aid flow (current US$) of Tanzania in 2002 to that in 2004?
Your answer should be compact. 0.61. What is the ratio of the Aid flow (current US$) in High income: nonOECD in 2002 to that in 2005?
Ensure brevity in your answer.  5.55. What is the ratio of the Aid flow (current US$) of Sudan in 2002 to that in 2005?
Make the answer very short. 0.06. What is the ratio of the Aid flow (current US$) in Tanzania in 2002 to that in 2005?
Make the answer very short. 0.51. What is the ratio of the Aid flow (current US$) in High income: nonOECD in 2002 to that in 2006?
Provide a short and direct response. 5.55. What is the ratio of the Aid flow (current US$) in Sudan in 2002 to that in 2006?
Ensure brevity in your answer.  0.12. What is the ratio of the Aid flow (current US$) of Tanzania in 2002 to that in 2006?
Your answer should be very brief. 0.38. What is the ratio of the Aid flow (current US$) of High income: nonOECD in 2002 to that in 2007?
Offer a terse response. 4.36. What is the ratio of the Aid flow (current US$) in Bhutan in 2002 to that in 2007?
Keep it short and to the point. 0.91. What is the ratio of the Aid flow (current US$) in Sudan in 2002 to that in 2007?
Offer a terse response. 0.1. What is the ratio of the Aid flow (current US$) in Tanzania in 2002 to that in 2007?
Offer a terse response. 0.56. What is the ratio of the Aid flow (current US$) in High income: nonOECD in 2003 to that in 2004?
Ensure brevity in your answer.  1. What is the ratio of the Aid flow (current US$) of Bhutan in 2003 to that in 2004?
Your response must be concise. 0.72. What is the ratio of the Aid flow (current US$) in Sudan in 2003 to that in 2004?
Your answer should be very brief. 0.27. What is the ratio of the Aid flow (current US$) in Tanzania in 2003 to that in 2004?
Ensure brevity in your answer.  1.07. What is the ratio of the Aid flow (current US$) in High income: nonOECD in 2003 to that in 2005?
Your response must be concise. 7.55. What is the ratio of the Aid flow (current US$) in Bhutan in 2003 to that in 2005?
Provide a succinct answer. 0.74. What is the ratio of the Aid flow (current US$) of Sudan in 2003 to that in 2005?
Offer a terse response. 0.32. What is the ratio of the Aid flow (current US$) of Tanzania in 2003 to that in 2005?
Provide a short and direct response. 0.9. What is the ratio of the Aid flow (current US$) in High income: nonOECD in 2003 to that in 2006?
Your response must be concise. 7.55. What is the ratio of the Aid flow (current US$) of Bhutan in 2003 to that in 2006?
Your answer should be very brief. 1.44. What is the ratio of the Aid flow (current US$) of Sudan in 2003 to that in 2006?
Provide a short and direct response. 0.63. What is the ratio of the Aid flow (current US$) in Tanzania in 2003 to that in 2006?
Offer a terse response. 0.66. What is the ratio of the Aid flow (current US$) in High income: nonOECD in 2003 to that in 2007?
Give a very brief answer. 5.93. What is the ratio of the Aid flow (current US$) in Bhutan in 2003 to that in 2007?
Offer a very short reply. 1.18. What is the ratio of the Aid flow (current US$) in Sudan in 2003 to that in 2007?
Offer a very short reply. 0.53. What is the ratio of the Aid flow (current US$) of Tanzania in 2003 to that in 2007?
Provide a succinct answer. 0.99. What is the ratio of the Aid flow (current US$) of High income: nonOECD in 2004 to that in 2005?
Give a very brief answer. 7.55. What is the ratio of the Aid flow (current US$) in Bhutan in 2004 to that in 2005?
Give a very brief answer. 1.03. What is the ratio of the Aid flow (current US$) in Sudan in 2004 to that in 2005?
Offer a very short reply. 1.2. What is the ratio of the Aid flow (current US$) in Tanzania in 2004 to that in 2005?
Provide a succinct answer. 0.84. What is the ratio of the Aid flow (current US$) in High income: nonOECD in 2004 to that in 2006?
Your answer should be very brief. 7.55. What is the ratio of the Aid flow (current US$) in Bhutan in 2004 to that in 2006?
Your answer should be compact. 2. What is the ratio of the Aid flow (current US$) of Sudan in 2004 to that in 2006?
Keep it short and to the point. 2.38. What is the ratio of the Aid flow (current US$) in Tanzania in 2004 to that in 2006?
Provide a short and direct response. 0.62. What is the ratio of the Aid flow (current US$) of High income: nonOECD in 2004 to that in 2007?
Offer a terse response. 5.93. What is the ratio of the Aid flow (current US$) in Bhutan in 2004 to that in 2007?
Ensure brevity in your answer.  1.64. What is the ratio of the Aid flow (current US$) in Sudan in 2004 to that in 2007?
Provide a short and direct response. 1.99. What is the ratio of the Aid flow (current US$) of Tanzania in 2004 to that in 2007?
Ensure brevity in your answer.  0.93. What is the ratio of the Aid flow (current US$) of Bhutan in 2005 to that in 2006?
Your answer should be compact. 1.94. What is the ratio of the Aid flow (current US$) in Sudan in 2005 to that in 2006?
Give a very brief answer. 1.98. What is the ratio of the Aid flow (current US$) in Tanzania in 2005 to that in 2006?
Provide a succinct answer. 0.73. What is the ratio of the Aid flow (current US$) in High income: nonOECD in 2005 to that in 2007?
Provide a succinct answer. 0.79. What is the ratio of the Aid flow (current US$) in Bhutan in 2005 to that in 2007?
Give a very brief answer. 1.59. What is the ratio of the Aid flow (current US$) of Sudan in 2005 to that in 2007?
Offer a terse response. 1.65. What is the ratio of the Aid flow (current US$) of Tanzania in 2005 to that in 2007?
Offer a terse response. 1.1. What is the ratio of the Aid flow (current US$) in High income: nonOECD in 2006 to that in 2007?
Make the answer very short. 0.79. What is the ratio of the Aid flow (current US$) of Bhutan in 2006 to that in 2007?
Provide a succinct answer. 0.82. What is the ratio of the Aid flow (current US$) of Sudan in 2006 to that in 2007?
Offer a terse response. 0.83. What is the ratio of the Aid flow (current US$) of Tanzania in 2006 to that in 2007?
Provide a short and direct response. 1.5. What is the difference between the highest and the second highest Aid flow (current US$) in High income: nonOECD?
Your answer should be very brief. 0. What is the difference between the highest and the second highest Aid flow (current US$) of Bhutan?
Offer a very short reply. 10000. What is the difference between the highest and the second highest Aid flow (current US$) in Sudan?
Provide a short and direct response. 7.40e+05. What is the difference between the highest and the lowest Aid flow (current US$) in High income: nonOECD?
Make the answer very short. 7.20e+05. What is the difference between the highest and the lowest Aid flow (current US$) of Bhutan?
Your response must be concise. 1.80e+05. What is the difference between the highest and the lowest Aid flow (current US$) of Sudan?
Your answer should be very brief. 4.20e+06. What is the difference between the highest and the lowest Aid flow (current US$) in Tanzania?
Your answer should be very brief. 1.01e+06. 